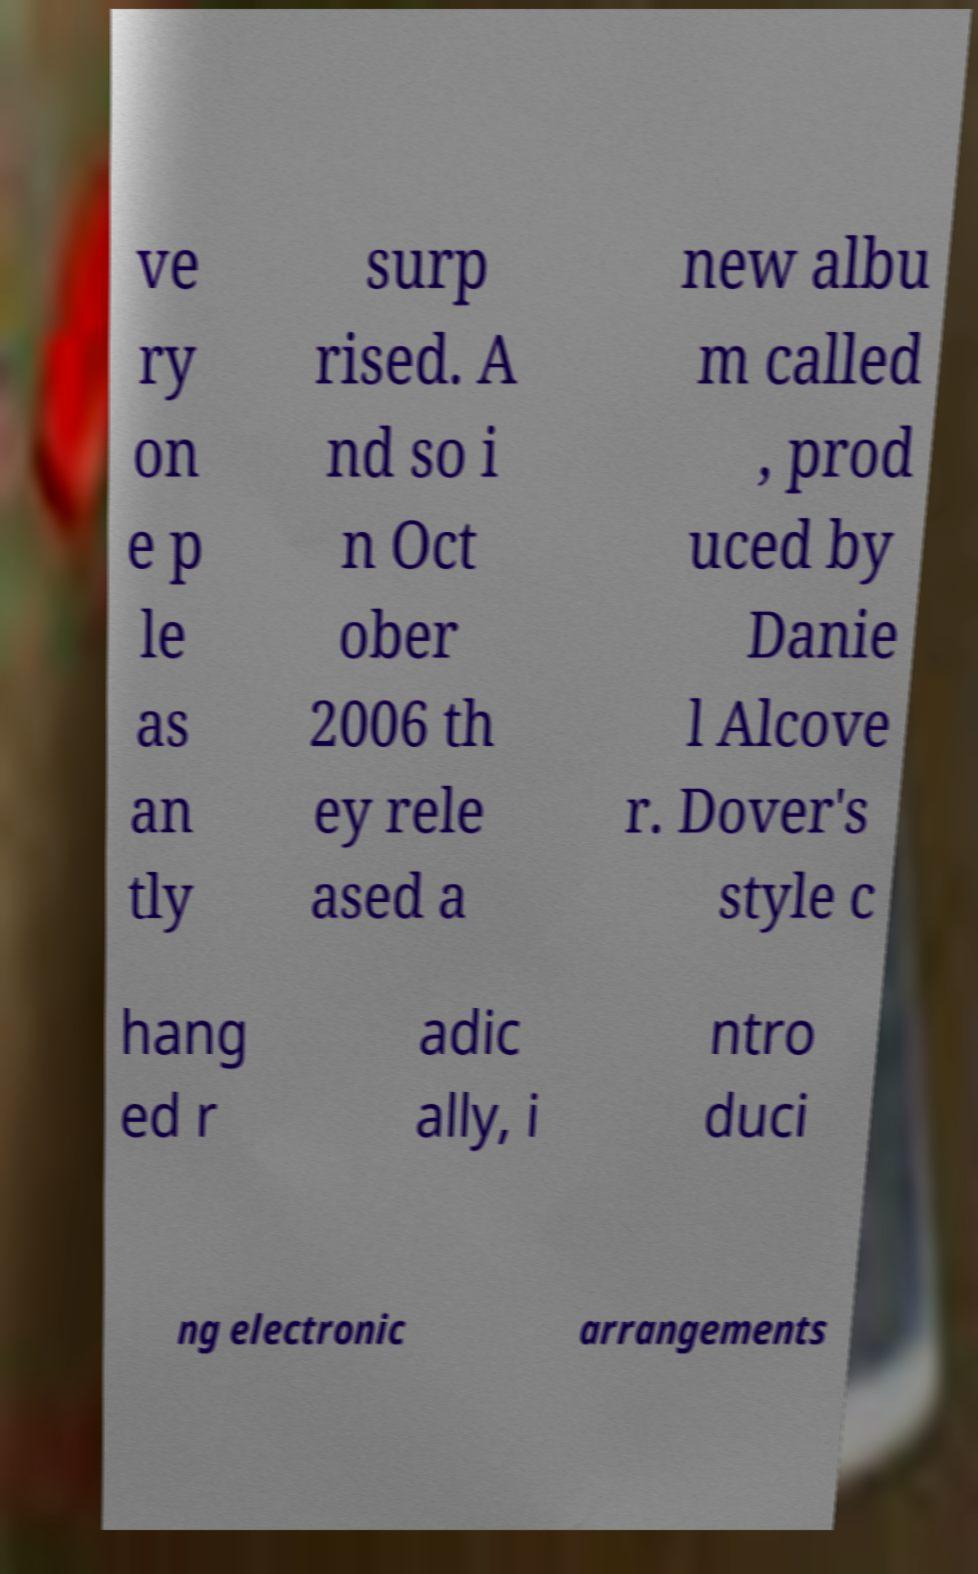Can you read and provide the text displayed in the image?This photo seems to have some interesting text. Can you extract and type it out for me? ve ry on e p le as an tly surp rised. A nd so i n Oct ober 2006 th ey rele ased a new albu m called , prod uced by Danie l Alcove r. Dover's style c hang ed r adic ally, i ntro duci ng electronic arrangements 